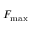Convert formula to latex. <formula><loc_0><loc_0><loc_500><loc_500>F _ { \max }</formula> 